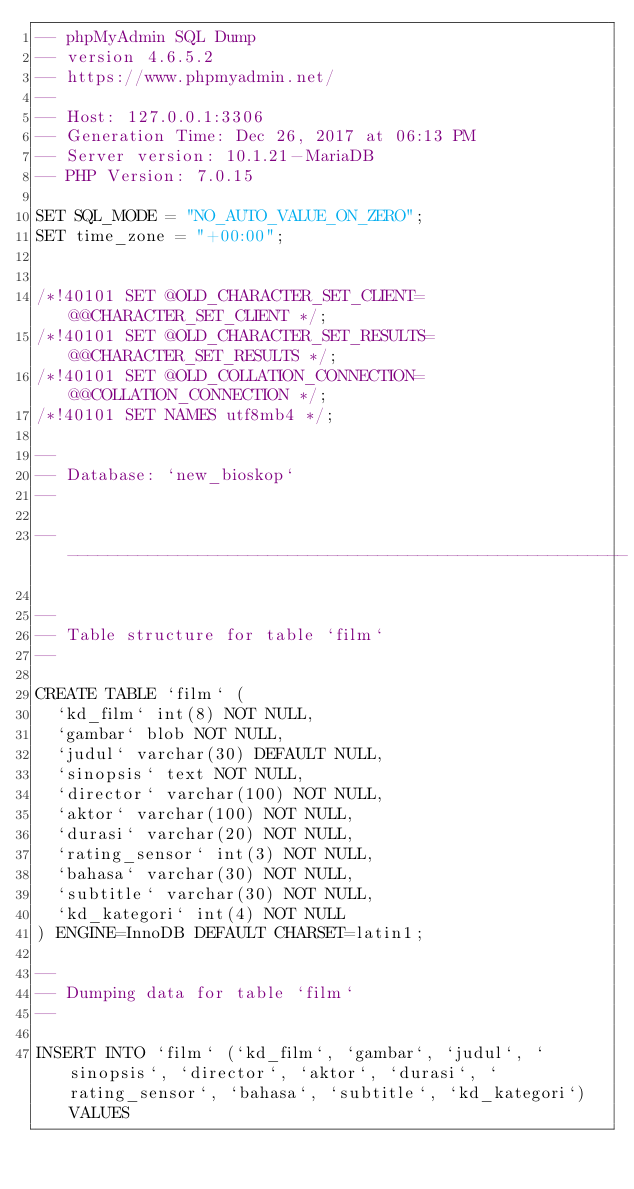Convert code to text. <code><loc_0><loc_0><loc_500><loc_500><_SQL_>-- phpMyAdmin SQL Dump
-- version 4.6.5.2
-- https://www.phpmyadmin.net/
--
-- Host: 127.0.0.1:3306
-- Generation Time: Dec 26, 2017 at 06:13 PM
-- Server version: 10.1.21-MariaDB
-- PHP Version: 7.0.15

SET SQL_MODE = "NO_AUTO_VALUE_ON_ZERO";
SET time_zone = "+00:00";


/*!40101 SET @OLD_CHARACTER_SET_CLIENT=@@CHARACTER_SET_CLIENT */;
/*!40101 SET @OLD_CHARACTER_SET_RESULTS=@@CHARACTER_SET_RESULTS */;
/*!40101 SET @OLD_COLLATION_CONNECTION=@@COLLATION_CONNECTION */;
/*!40101 SET NAMES utf8mb4 */;

--
-- Database: `new_bioskop`
--

-- --------------------------------------------------------

--
-- Table structure for table `film`
--

CREATE TABLE `film` (
  `kd_film` int(8) NOT NULL,
  `gambar` blob NOT NULL,
  `judul` varchar(30) DEFAULT NULL,
  `sinopsis` text NOT NULL,
  `director` varchar(100) NOT NULL,
  `aktor` varchar(100) NOT NULL,
  `durasi` varchar(20) NOT NULL,
  `rating_sensor` int(3) NOT NULL,
  `bahasa` varchar(30) NOT NULL,
  `subtitle` varchar(30) NOT NULL,
  `kd_kategori` int(4) NOT NULL
) ENGINE=InnoDB DEFAULT CHARSET=latin1;

--
-- Dumping data for table `film`
--

INSERT INTO `film` (`kd_film`, `gambar`, `judul`, `sinopsis`, `director`, `aktor`, `durasi`, `rating_sensor`, `bahasa`, `subtitle`, `kd_kategori`) VALUES</code> 